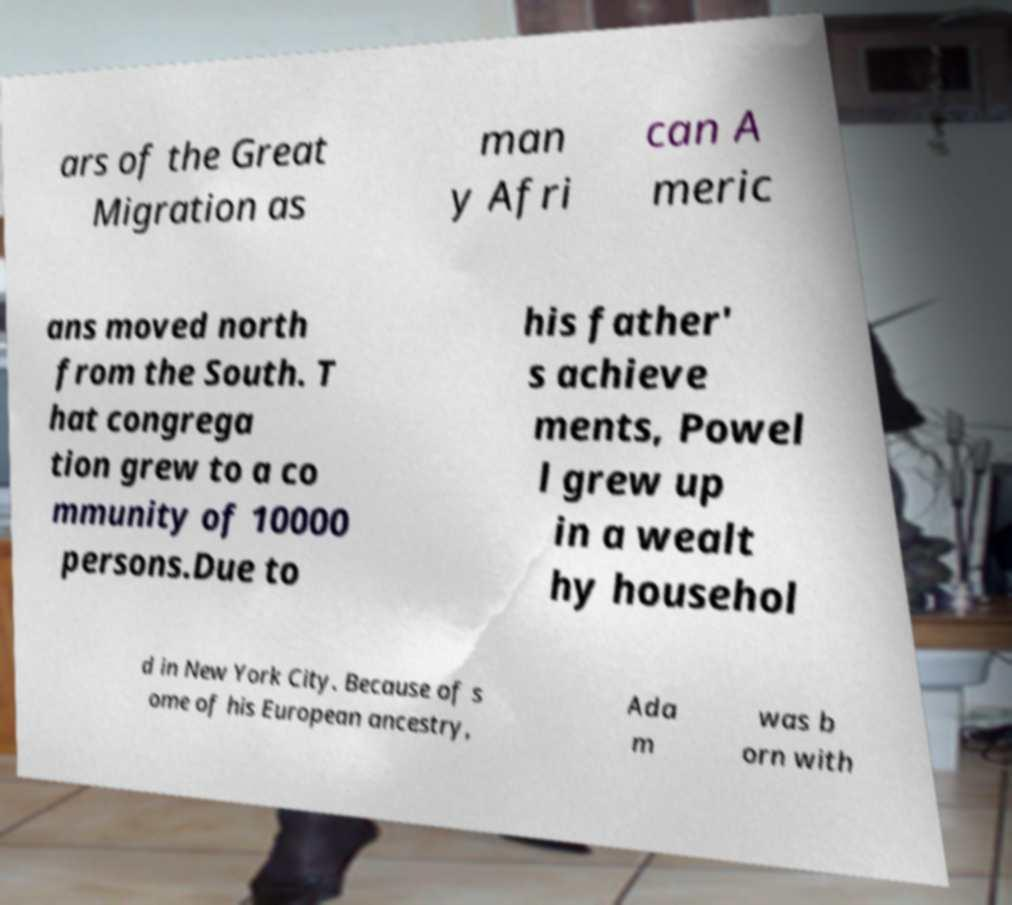Could you extract and type out the text from this image? ars of the Great Migration as man y Afri can A meric ans moved north from the South. T hat congrega tion grew to a co mmunity of 10000 persons.Due to his father' s achieve ments, Powel l grew up in a wealt hy househol d in New York City. Because of s ome of his European ancestry, Ada m was b orn with 